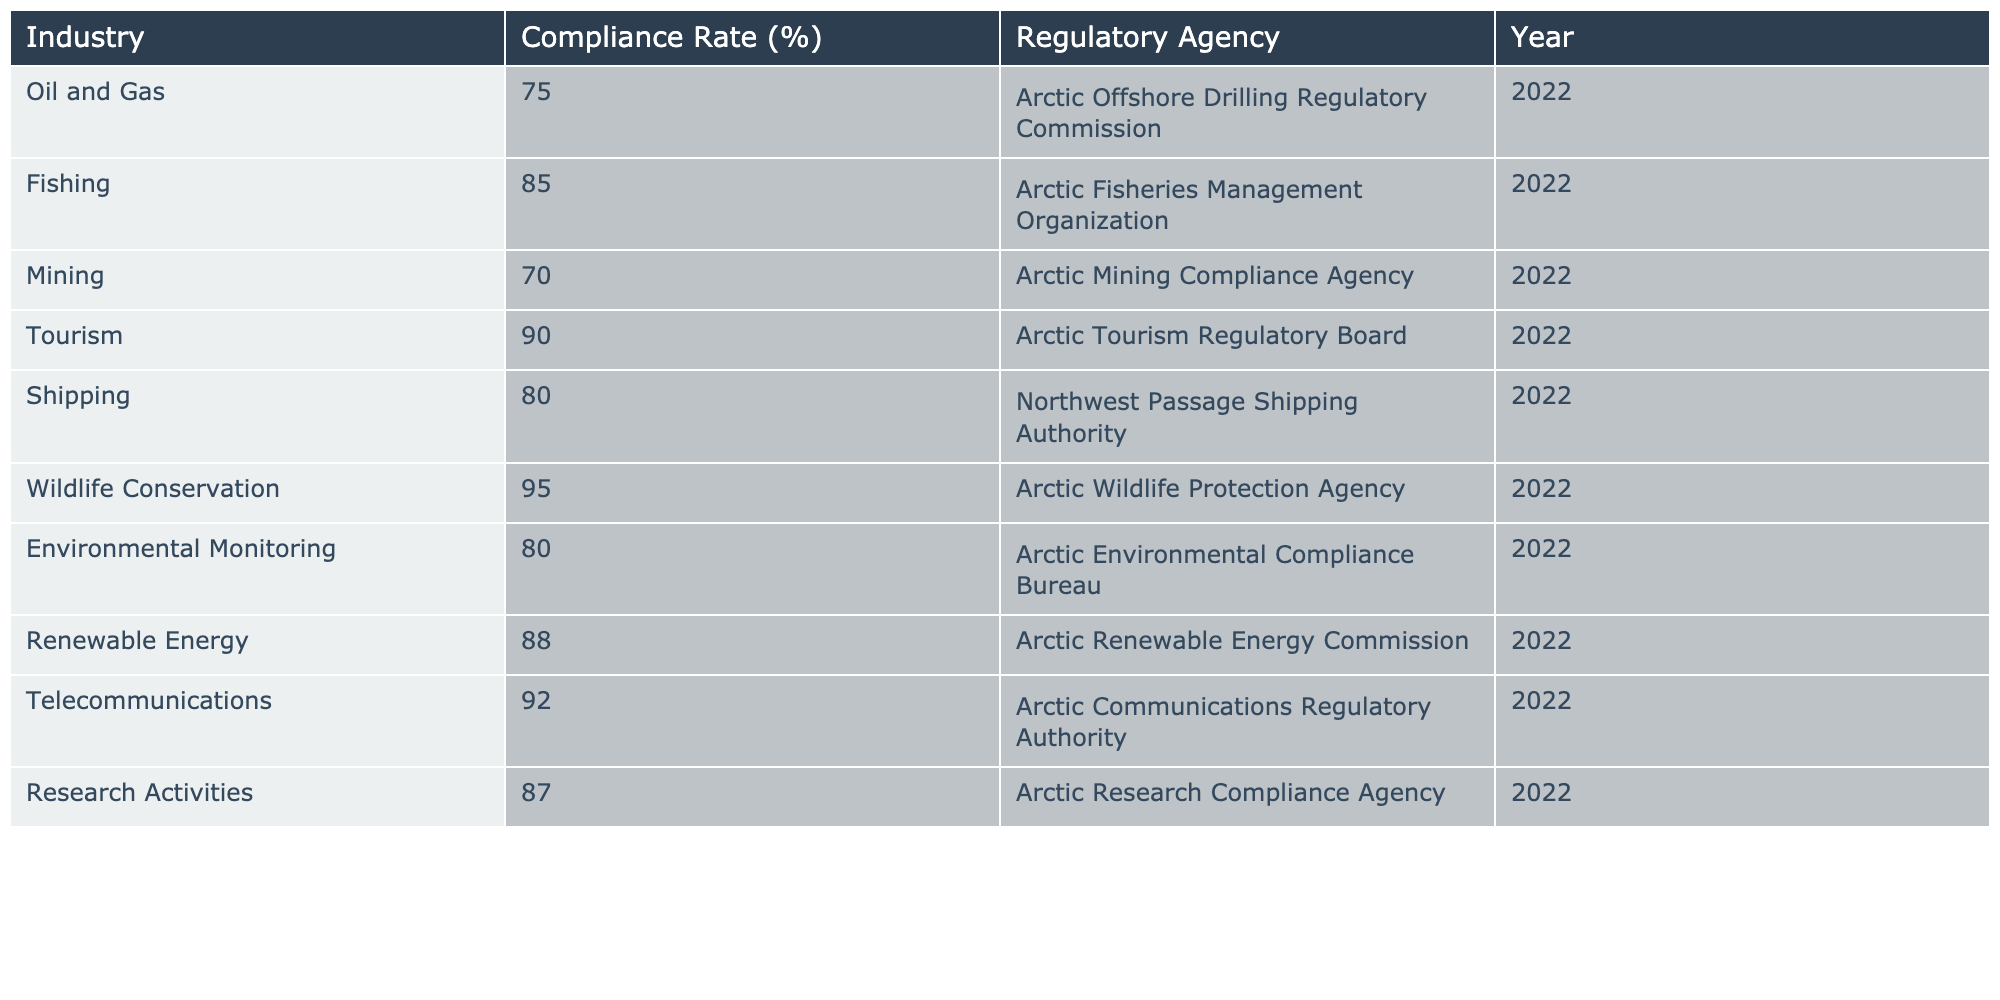What is the compliance rate percentage for the Oil and Gas industry? Looking at the table, the Oil and Gas industry has a compliance rate of 75%.
Answer: 75% Which industry has the highest compliance rate? The Wildlife Conservation industry has the highest compliance rate at 95%.
Answer: 95% Is the compliance rate for Shipping above or below 85%? The Shipping industry has a compliance rate of 80%, which is below 85%.
Answer: Below What is the average compliance rate of the industries listed in the table? The compliance rates are: 75, 85, 70, 90, 80, 95, 80, 88, 92, 87. The sum of these rates is  75 + 85 + 70 + 90 + 80 + 95 + 80 + 88 + 92 + 87 =  87. The average is  87/10 = 87%.
Answer: 87% How many industries have compliance rates higher than 80%? The industries with rates higher than 80% are Fishing (85%), Tourism (90%), Wildlife Conservation (95%), Telecommunications (92%), and Research Activities (87%). There are 5 such industries.
Answer: 5 What is the difference in compliance rates between Mining and Renewable Energy? Mining has a compliance rate of 70% and Renewable Energy has 88%. The difference is calculated as 88 - 70 = 18%.
Answer: 18% Which regulatory agency oversees the Telecommunications industry? The Telecommunications industry is overseen by the Arctic Communications Regulatory Authority.
Answer: Arctic Communications Regulatory Authority If the compliance rates for Fishing and Mining were combined, what would be their average? Fishing has a compliance rate of 85% and Mining has 70%. To find their average, we calculate (85 + 70) / 2 = 77.5%.
Answer: 77.5% Is the compliance rate for Environmental Monitoring higher than that of the Oil and Gas industry? Environmental Monitoring has a compliance rate of 80%, while Oil and Gas has 75%. Therefore, Environmental Monitoring's compliance rate is higher.
Answer: Yes What percentage of the industries listed have a compliance rate of 85% or higher? The industries with compliance rates of 85% or higher are Fishing (85%), Tourism (90%), Wildlife Conservation (95%), Telecommunications (92%), and Research Activities (87%). That's 5 out of 10 industries, which means 50%.
Answer: 50% 